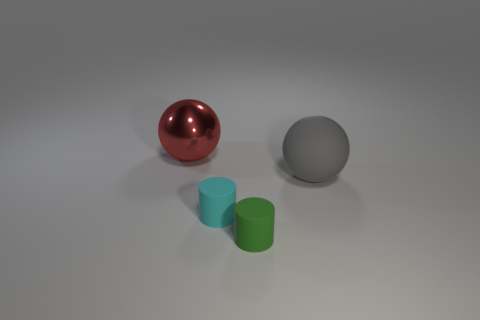Is there any other thing that is made of the same material as the large red ball?
Your response must be concise. No. Is there a rubber thing?
Offer a terse response. Yes. What number of things are big spheres behind the big gray matte thing or large spheres left of the cyan cylinder?
Provide a succinct answer. 1. Is the metallic thing the same color as the rubber sphere?
Give a very brief answer. No. Is the number of large cyan metallic spheres less than the number of big gray things?
Your answer should be very brief. Yes. There is a big gray ball; are there any big gray matte balls to the left of it?
Ensure brevity in your answer.  No. Are the big gray sphere and the red thing made of the same material?
Give a very brief answer. No. There is another object that is the same shape as the large gray thing; what is its color?
Provide a succinct answer. Red. Does the small matte cylinder left of the green matte thing have the same color as the big matte ball?
Offer a terse response. No. What number of red things have the same material as the big red sphere?
Provide a succinct answer. 0. 